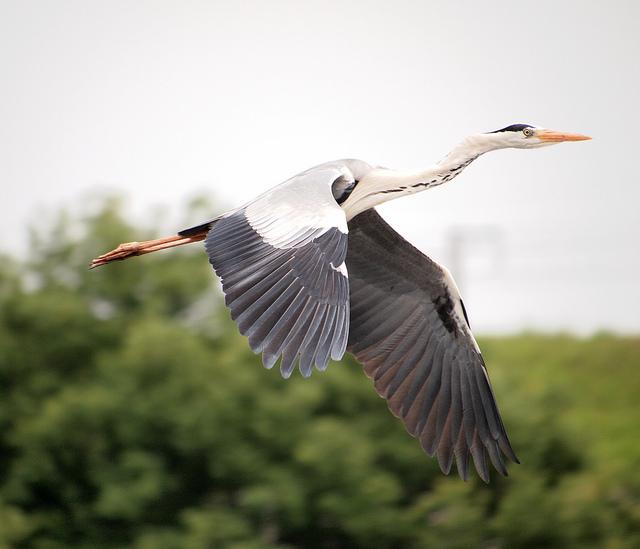Was this bird in the water?
Short answer required. No. What color are the feathers?
Keep it brief. Gray. What color is the beak?
Be succinct. Orange. Is the bird flying?
Write a very short answer. Yes. Is this bird flying?
Keep it brief. Yes. 